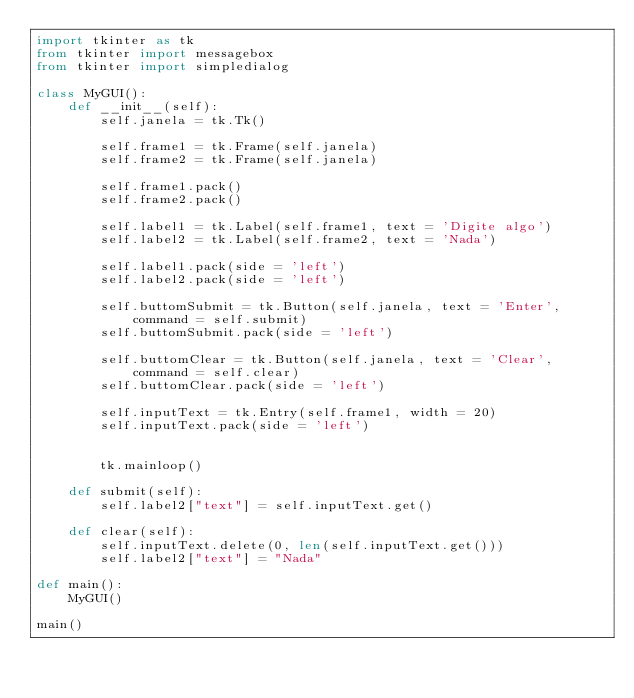<code> <loc_0><loc_0><loc_500><loc_500><_Python_>import tkinter as tk
from tkinter import messagebox
from tkinter import simpledialog

class MyGUI():
    def __init__(self):
        self.janela = tk.Tk()
    
        self.frame1 = tk.Frame(self.janela)
        self.frame2 = tk.Frame(self.janela)

        self.frame1.pack()
        self.frame2.pack()

        self.label1 = tk.Label(self.frame1, text = 'Digite algo')
        self.label2 = tk.Label(self.frame2, text = 'Nada')

        self.label1.pack(side = 'left')
        self.label2.pack(side = 'left')

        self.buttomSubmit = tk.Button(self.janela, text = 'Enter', command = self.submit)
        self.buttomSubmit.pack(side = 'left')

        self.buttomClear = tk.Button(self.janela, text = 'Clear', command = self.clear)
        self.buttomClear.pack(side = 'left')

        self.inputText = tk.Entry(self.frame1, width = 20)
        self.inputText.pack(side = 'left')

    
        tk.mainloop()

    def submit(self):
        self.label2["text"] = self.inputText.get()

    def clear(self):
        self.inputText.delete(0, len(self.inputText.get()))
        self.label2["text"] = "Nada"

def main():
    MyGUI()

main()


</code> 